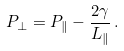<formula> <loc_0><loc_0><loc_500><loc_500>P _ { \perp } = P _ { \| } - \frac { 2 \gamma } { L _ { \| } } \, .</formula> 